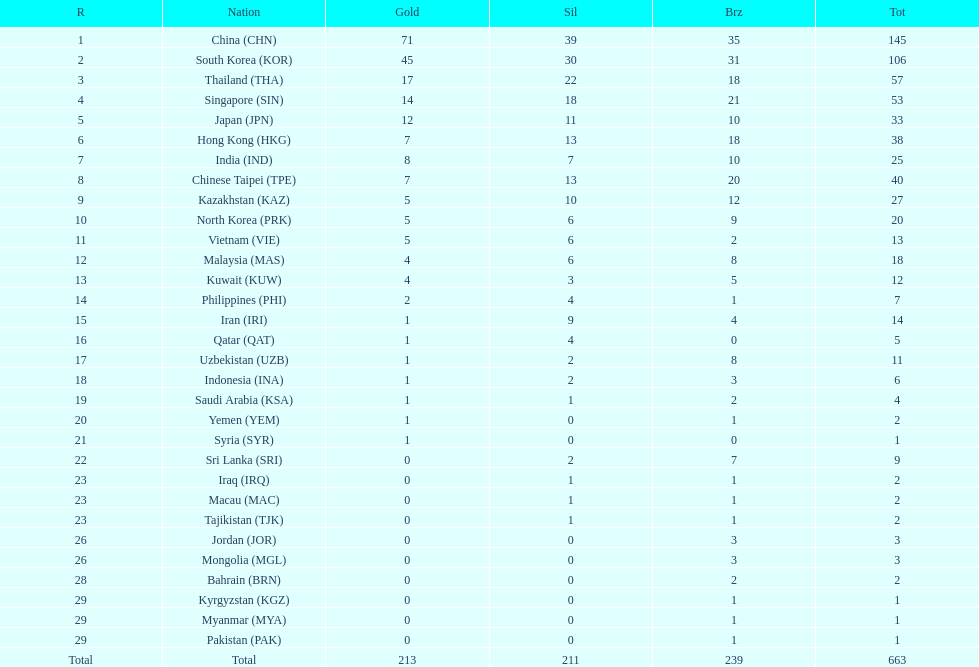How many nations earned at least ten bronze medals? 9. 